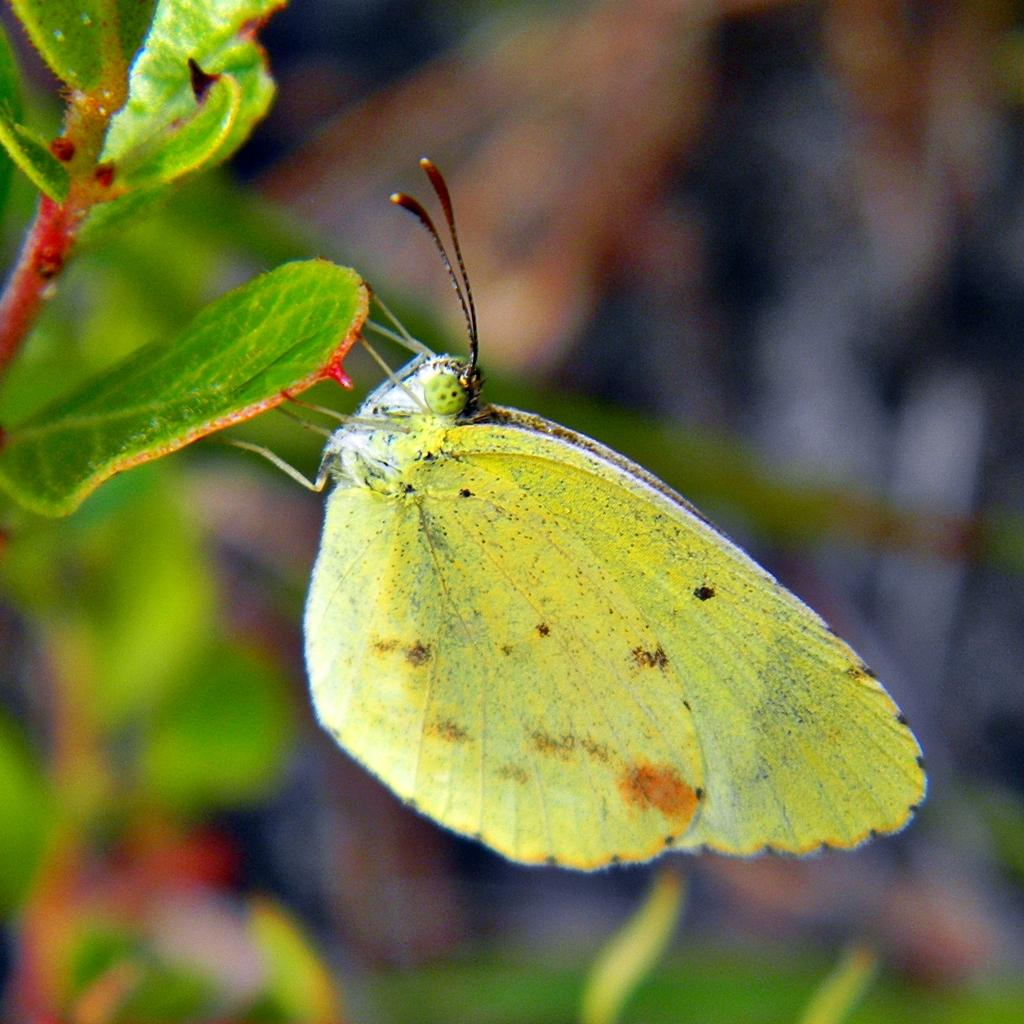What is the main subject of the image? The main subject of the image is a butterfly. What is the butterfly holding in the image? The butterfly is holding a leaf in the image. What can be inferred about the leaf's origin? The leaf belongs to a plant. What type of haircut does the butterfly have in the image? Butterflies do not have hair, so they cannot have haircuts. Can you explain the trick that the butterfly is performing in the image? There is no trick being performed by the butterfly in the image; it is simply holding a leaf. 